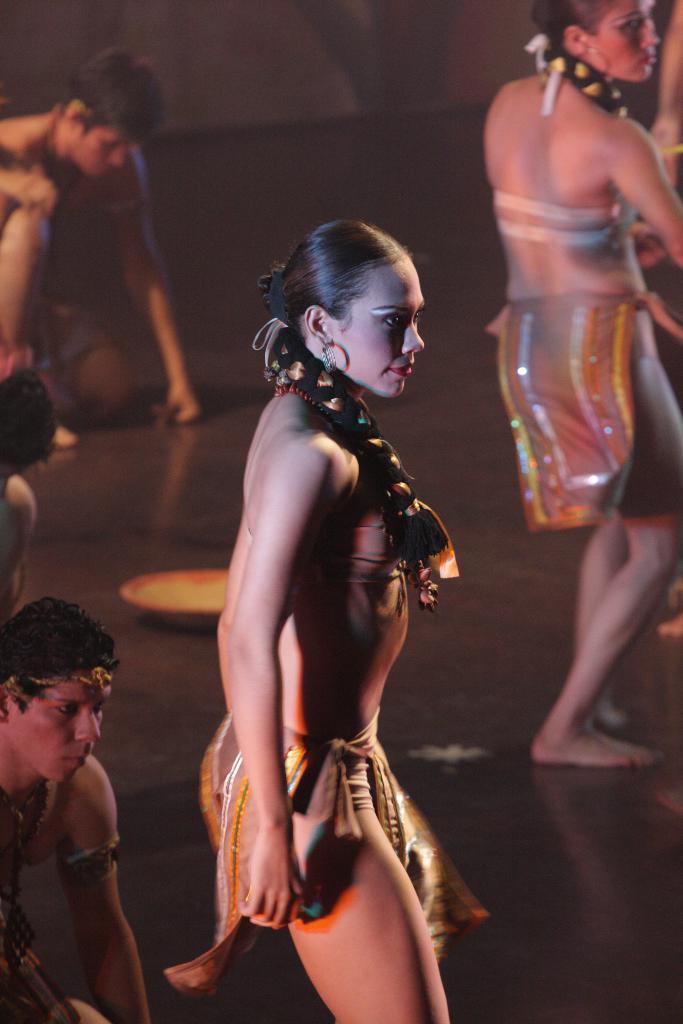Can you describe this image briefly? In this picture there are women and men dancing on a stage. In the background is blurred. 